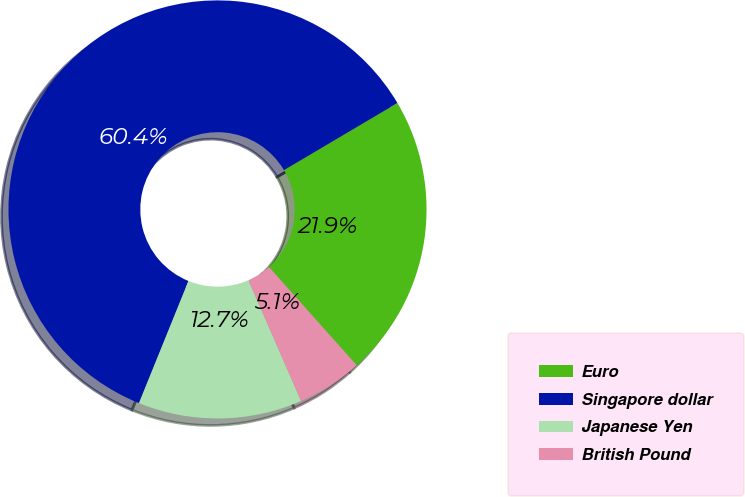Convert chart. <chart><loc_0><loc_0><loc_500><loc_500><pie_chart><fcel>Euro<fcel>Singapore dollar<fcel>Japanese Yen<fcel>British Pound<nl><fcel>21.9%<fcel>60.37%<fcel>12.68%<fcel>5.05%<nl></chart> 